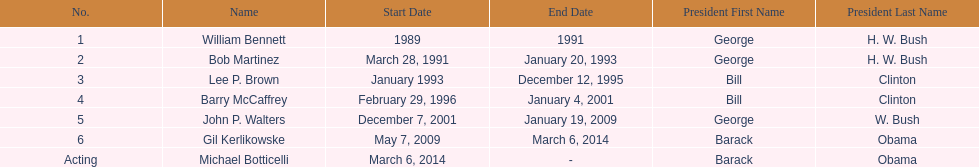When did john p. walters end his term? January 19, 2009. 